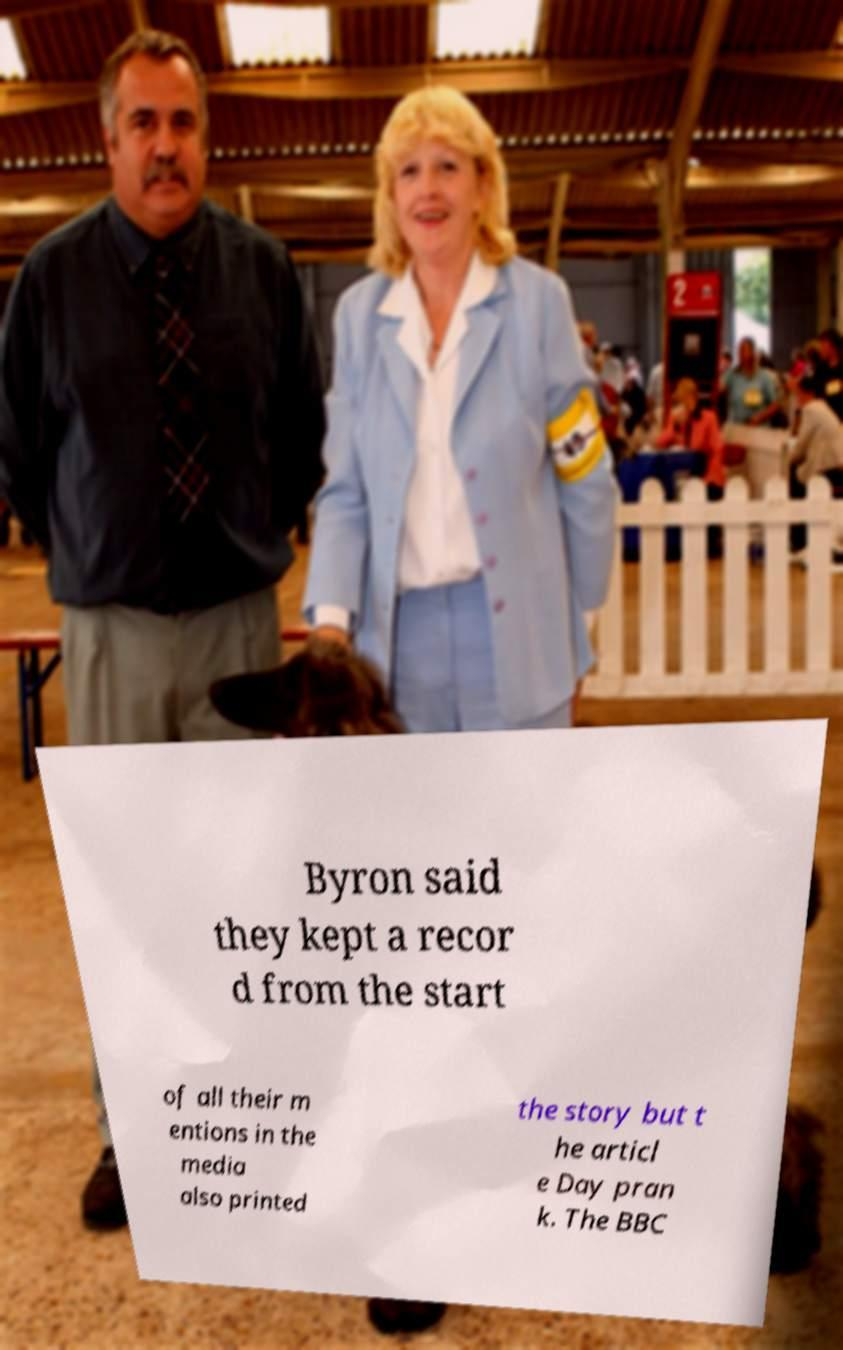Could you extract and type out the text from this image? Byron said they kept a recor d from the start of all their m entions in the media also printed the story but t he articl e Day pran k. The BBC 